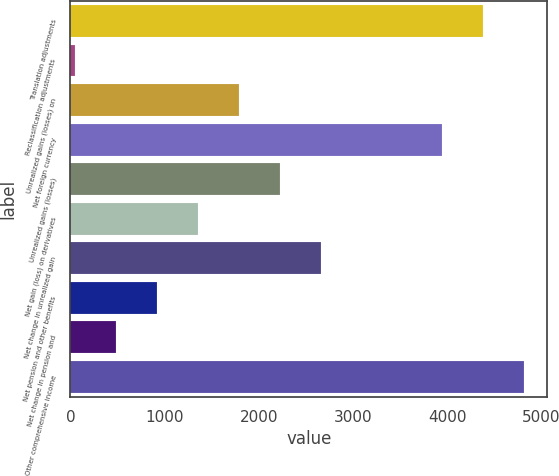<chart> <loc_0><loc_0><loc_500><loc_500><bar_chart><fcel>Translation adjustments<fcel>Reclassification adjustments<fcel>Unrealized gains (losses) on<fcel>Net foreign currency<fcel>Unrealized gains (losses)<fcel>Net gain (loss) on derivatives<fcel>Net change in unrealized gain<fcel>Net pension and other benefits<fcel>Net change in pension and<fcel>Other comprehensive income<nl><fcel>4383<fcel>49<fcel>1788.2<fcel>3941<fcel>2223<fcel>1353.4<fcel>2657.8<fcel>918.6<fcel>483.8<fcel>4817.8<nl></chart> 